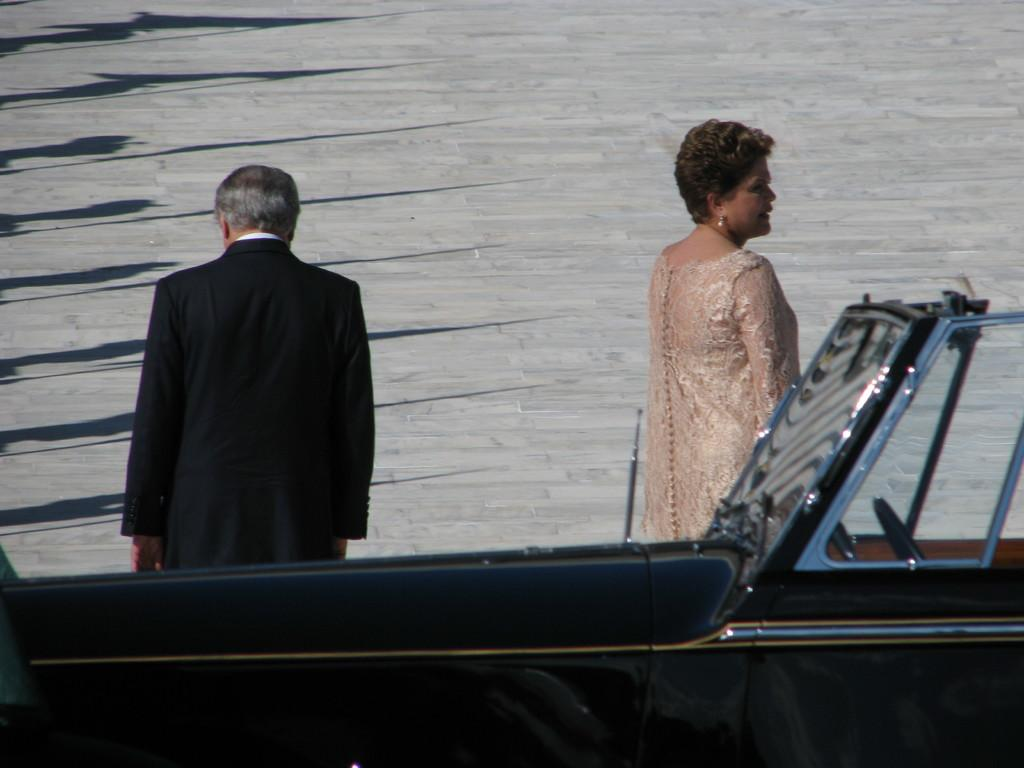Who can be seen in the image? There is a man and a woman in the image. What are the man and woman doing in the image? The man and woman are walking. What is located at the bottom of the image? There is a vehicle at the bottom of the image. What can be seen in the background of the image? There is a walkway in the background of the image. What color is the straw in the image? There is no straw present in the image. How many people are in the crowd in the image? There is no crowd present in the image; it features a man and a woman walking. 